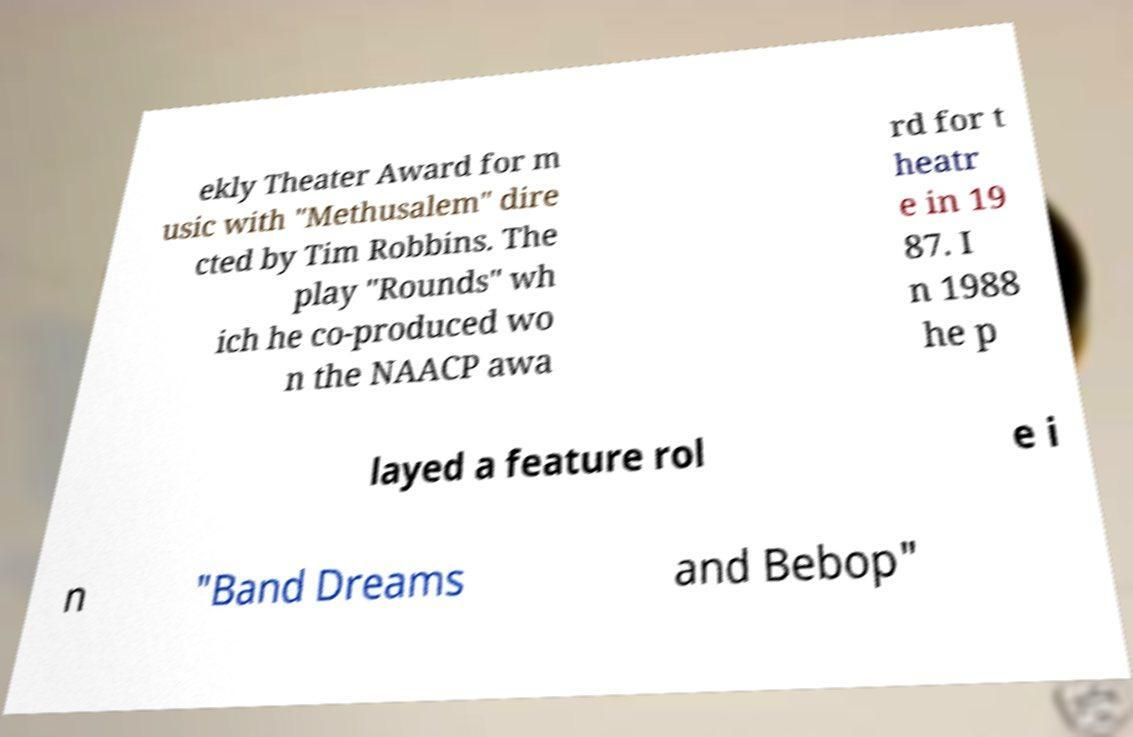Can you read and provide the text displayed in the image?This photo seems to have some interesting text. Can you extract and type it out for me? ekly Theater Award for m usic with "Methusalem" dire cted by Tim Robbins. The play "Rounds" wh ich he co-produced wo n the NAACP awa rd for t heatr e in 19 87. I n 1988 he p layed a feature rol e i n "Band Dreams and Bebop" 